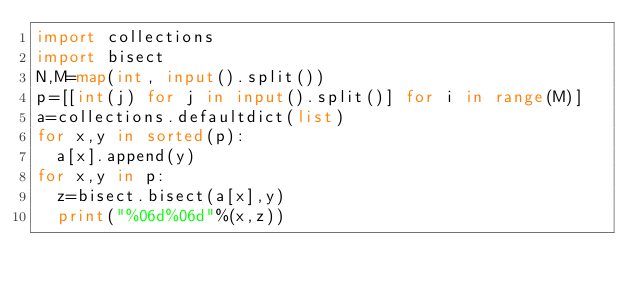Convert code to text. <code><loc_0><loc_0><loc_500><loc_500><_Python_>import collections
import bisect
N,M=map(int, input().split())
p=[[int(j) for j in input().split()] for i in range(M)]
a=collections.defaultdict(list)
for x,y in sorted(p):
  a[x].append(y)
for x,y in p:
  z=bisect.bisect(a[x],y)
  print("%06d%06d"%(x,z))</code> 